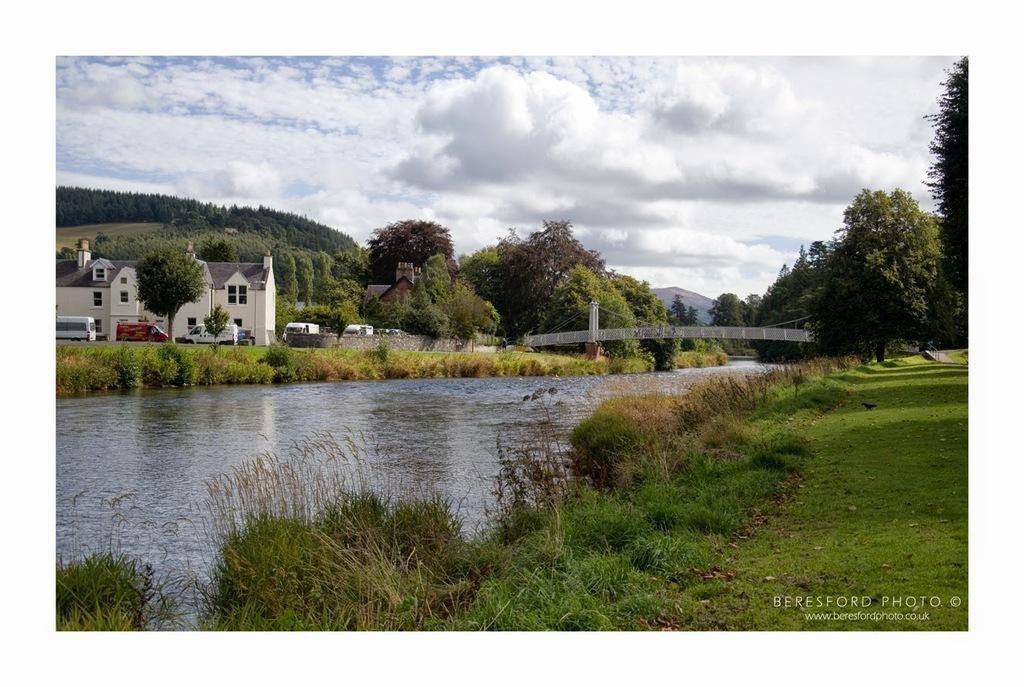Could you give a brief overview of what you see in this image? This picture is clicked outside. In the foreground we can see the green grass, plants and a water body. In the background we can see the sky which is full of clouds and we can see the trees, buildings, vehicles, bridge and at the bottom right corner we can see the text on the image. 